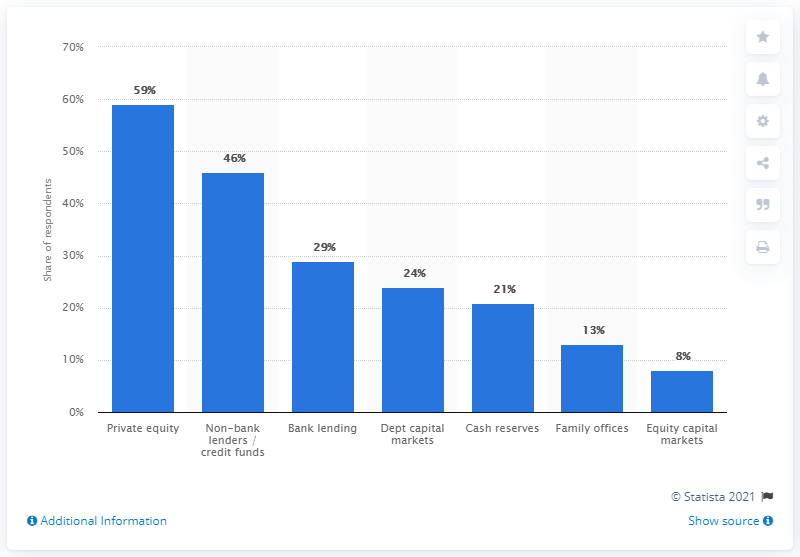Point out several critical features in this image. According to the survey, private equity was the main source of funding for corporate mergers and acquisitions (M&A) among 59% of respondents. 